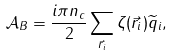<formula> <loc_0><loc_0><loc_500><loc_500>\mathcal { A } _ { B } = \frac { i \pi n _ { c } } { 2 } \sum _ { \vec { r } _ { i } } \zeta ( \vec { r } _ { i } ) \widetilde { q } _ { i } ,</formula> 